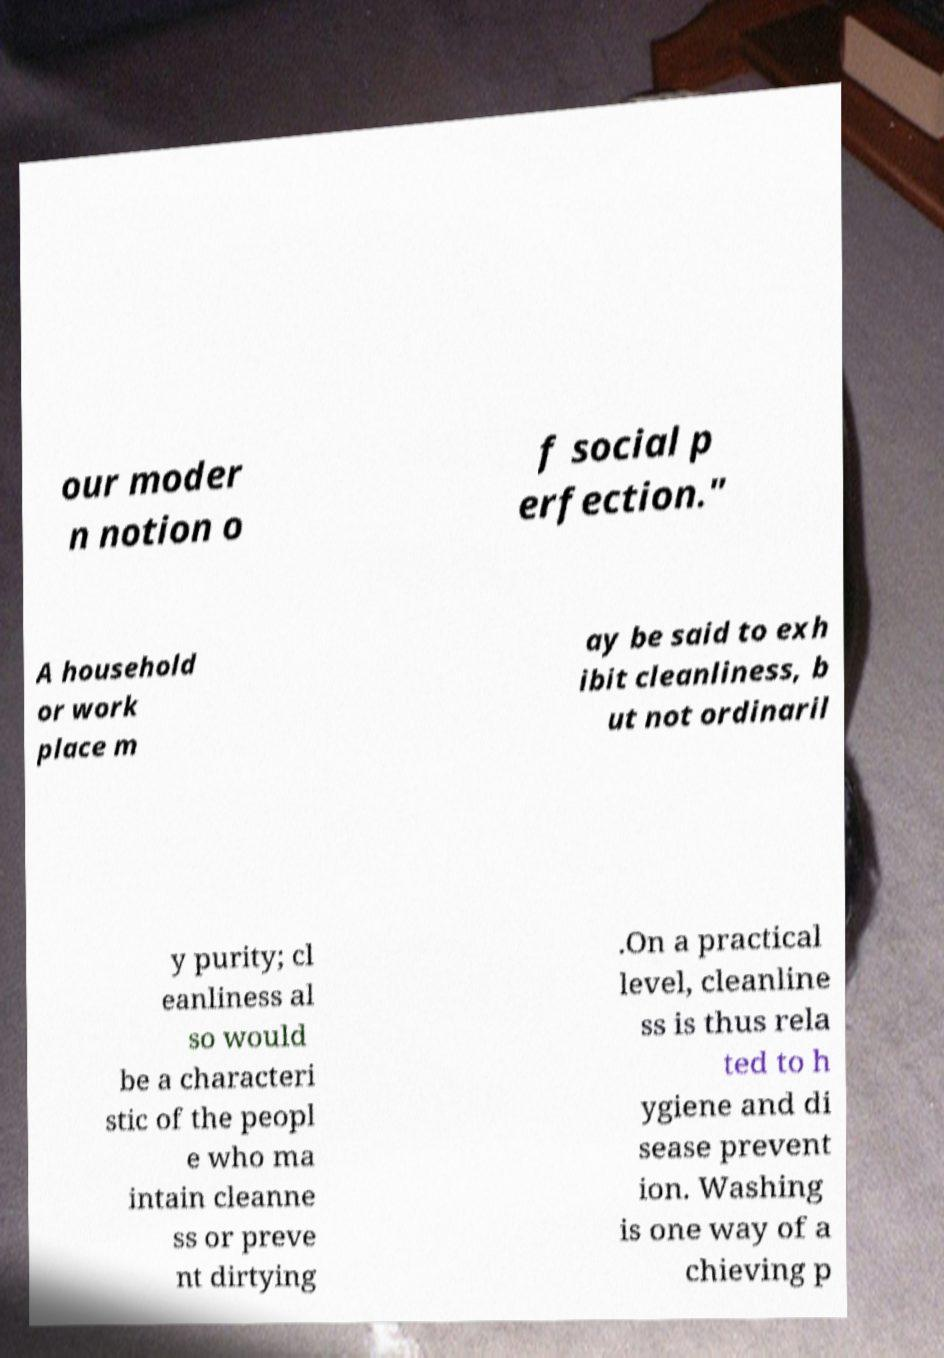There's text embedded in this image that I need extracted. Can you transcribe it verbatim? our moder n notion o f social p erfection." A household or work place m ay be said to exh ibit cleanliness, b ut not ordinaril y purity; cl eanliness al so would be a characteri stic of the peopl e who ma intain cleanne ss or preve nt dirtying .On a practical level, cleanline ss is thus rela ted to h ygiene and di sease prevent ion. Washing is one way of a chieving p 